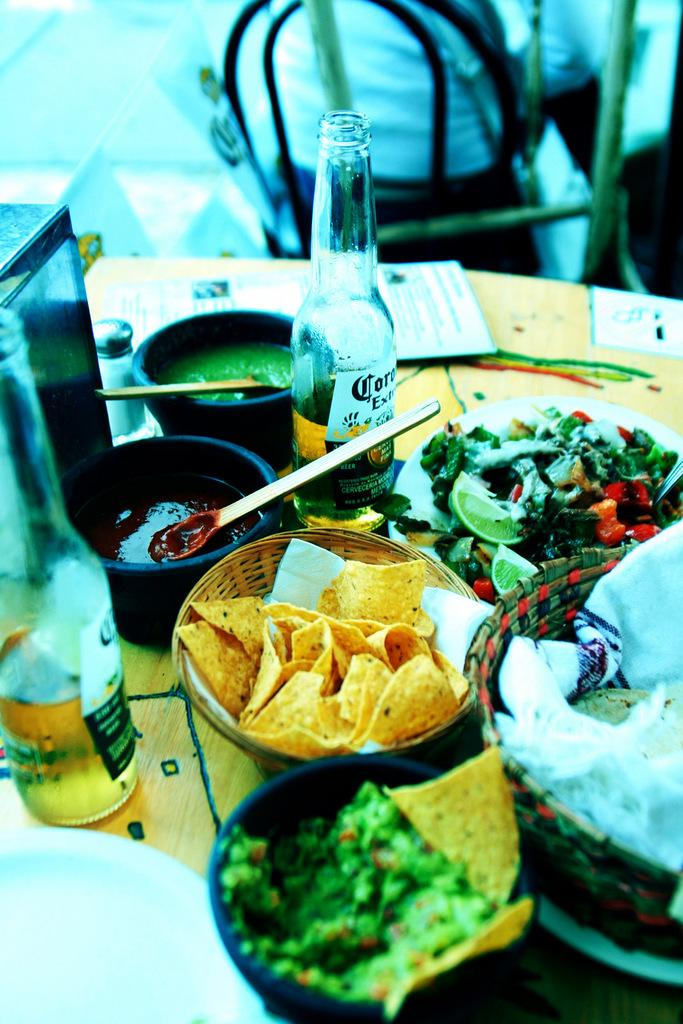<image>
Present a compact description of the photo's key features. A restaurant table with Hispanic food including chips, salsa, and a Corona extra beer. 